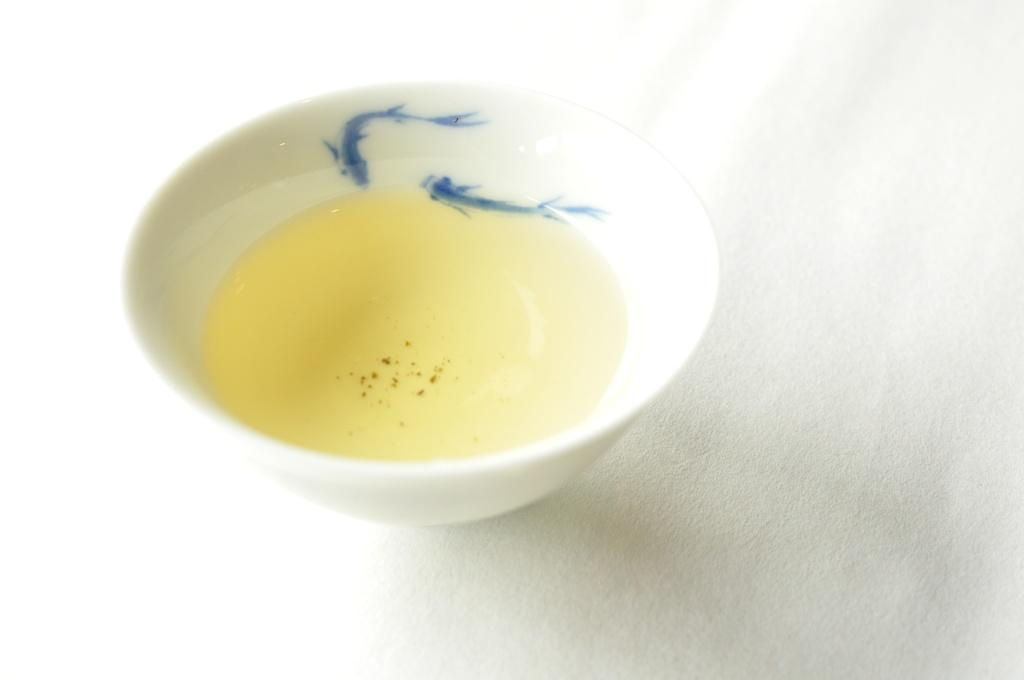What is in the image that contains liquid? There is a bowl in the image that contains liquid. What color is the surface beneath the bowl? The surface beneath the bowl is white. What type of yam is being used as a base for the meal in the image? There is no yam or meal present in the image; it only features a bowl containing liquid on a white surface. 